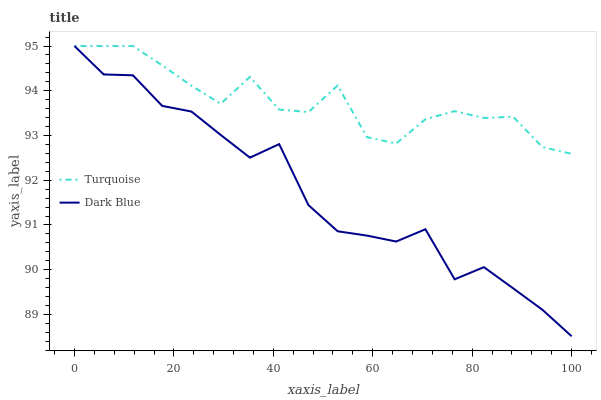Does Dark Blue have the minimum area under the curve?
Answer yes or no. Yes. Does Turquoise have the maximum area under the curve?
Answer yes or no. Yes. Does Turquoise have the minimum area under the curve?
Answer yes or no. No. Is Turquoise the smoothest?
Answer yes or no. Yes. Is Dark Blue the roughest?
Answer yes or no. Yes. Is Turquoise the roughest?
Answer yes or no. No. Does Dark Blue have the lowest value?
Answer yes or no. Yes. Does Turquoise have the lowest value?
Answer yes or no. No. Does Turquoise have the highest value?
Answer yes or no. Yes. Does Dark Blue intersect Turquoise?
Answer yes or no. Yes. Is Dark Blue less than Turquoise?
Answer yes or no. No. Is Dark Blue greater than Turquoise?
Answer yes or no. No. 